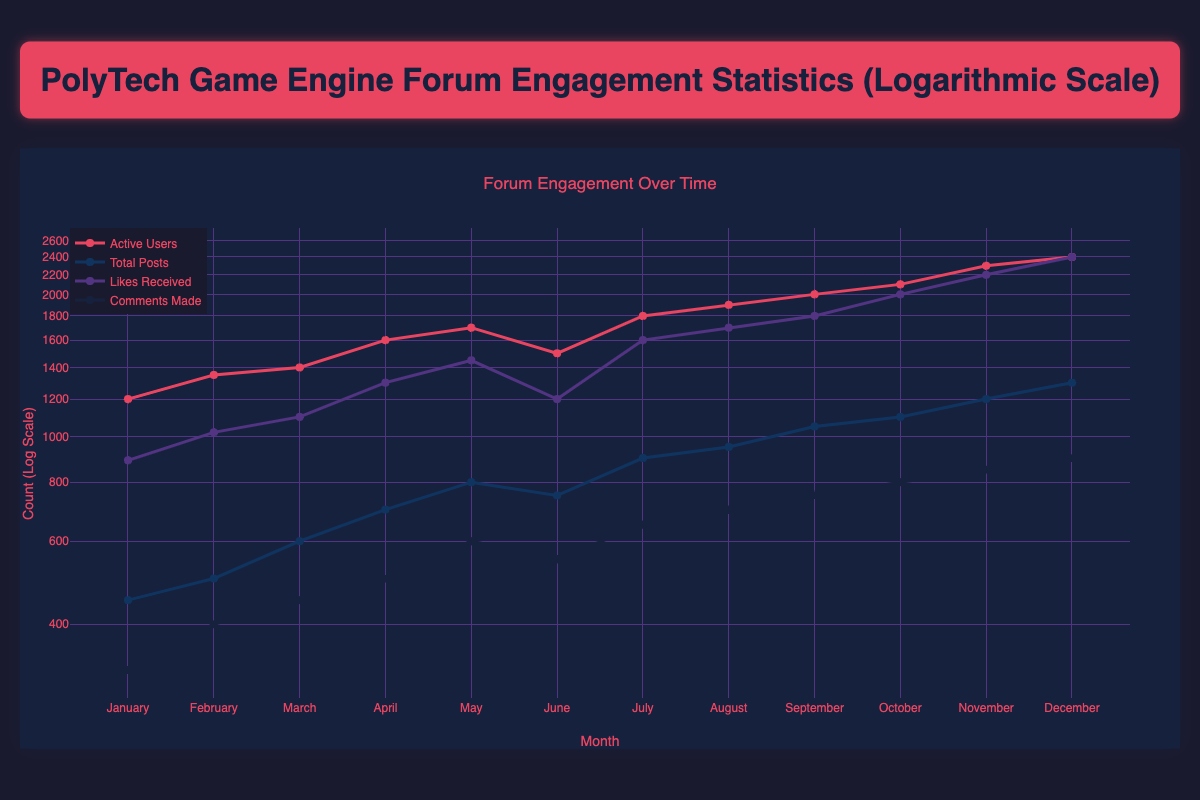What was the total number of likes received in December? In the data, December shows a total of 2400 likes received.
Answer: 2400 Which month had the highest number of active users? By reviewing the monthly active users, December shows the highest at 2400.
Answer: December What is the average total posts made over the months? The total posts from January to December are (450 + 500 + 600 + 700 + 800 + 750 + 900 + 950 + 1050 + 1100 + 1200 + 1300) = 10300. There are 12 months, so the average is 10300 / 12 ≈ 858.33.
Answer: 858.33 Did the likes received in July exceed the likes received in January? In July, there were 1600 likes received, while in January there were only 890. Since 1600 > 890, this statement is true.
Answer: Yes What is the difference in active users between November and February? In November, there were 2300 active users and in February, there were 1350. The difference is 2300 - 1350 = 950.
Answer: 950 Which month saw the largest increase in comments made compared to the previous month? By calculating the difference in comments for each month: January to February (400-320=80), February to March (450-400=50), March to April (500-450=50), April to May (600-500=100), May to June (550-600=-50), June to July (650-550=100), July to August (700-650=50), August to September (750-700=50), September to October (800-750=50), October to November (850-800=50), November to December (900-850=50). The largest increase was from April to May, with 100 comments.
Answer: April to May What is the total number of active users throughout the entire year? The total active users from January to December is (1200 + 1350 + 1400 + 1600 + 1700 + 1500 + 1800 + 1900 + 2000 + 2100 + 2300 + 2400) = 18500.
Answer: 18500 In which month did the forum have more total posts than likes received? Only June had 750 total posts and 1200 likes received; for all other months, likes received surpassed total posts.
Answer: June 